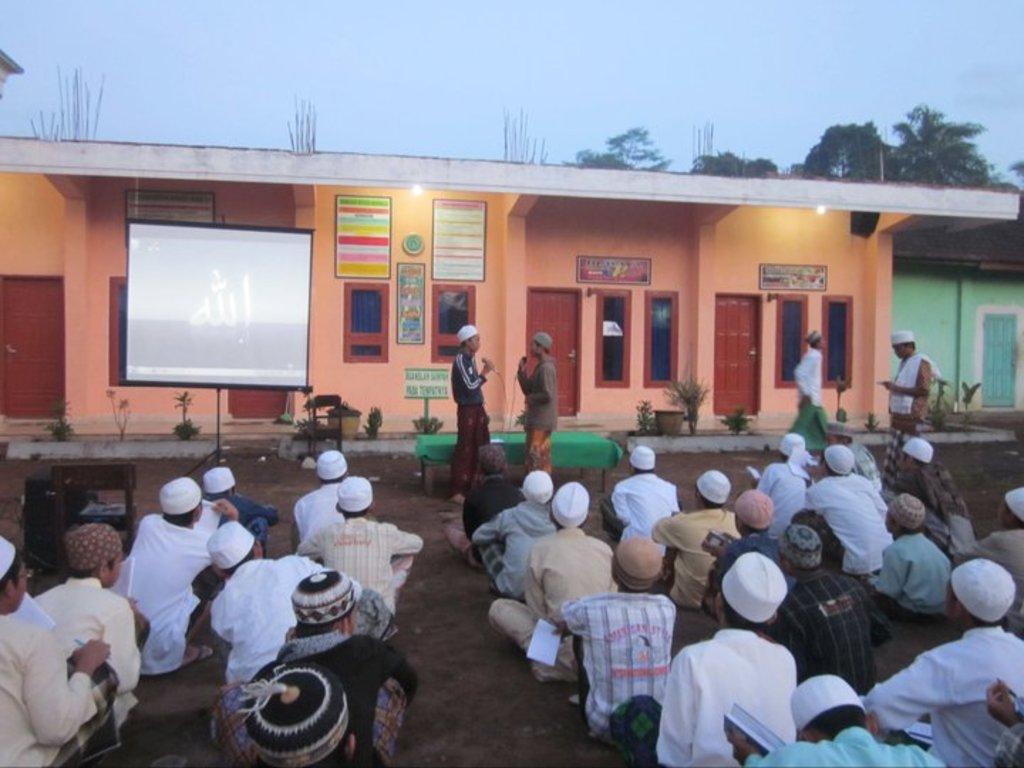Describe this image in one or two sentences. In this picture I can see a group of people are sitting on the ground at the bottom, in the middle two persons are speaking in the microphones, on the left side there is a projector screen. In the background there are frames on the wall, I can see a building, on the right side there are trees, at the top I can see the sky. 